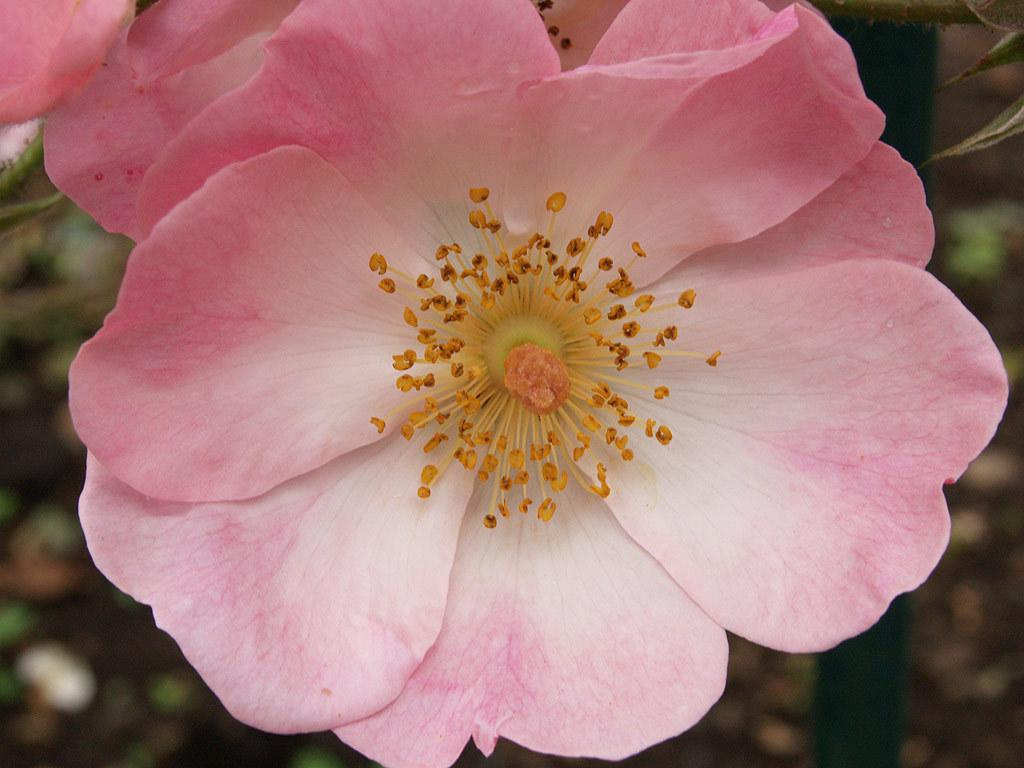What type of flower is in the image? There is a pink flower in the image. Can you describe the background of the image? The background of the image is blurred. What type of insurance policy is being discussed in the image? There is no mention of insurance or any discussion in the image; it only features a pink flower and a blurred background. 